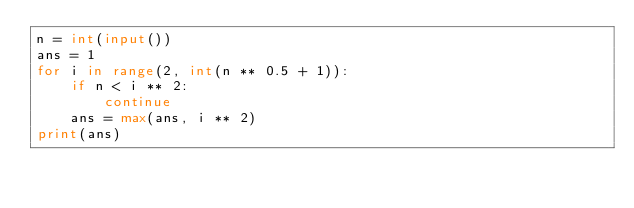Convert code to text. <code><loc_0><loc_0><loc_500><loc_500><_Python_>n = int(input())
ans = 1
for i in range(2, int(n ** 0.5 + 1)):
    if n < i ** 2:
        continue
    ans = max(ans, i ** 2)
print(ans)</code> 